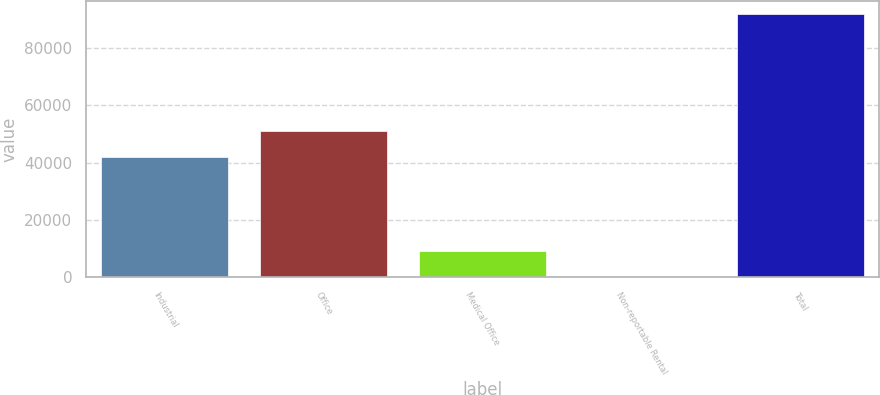Convert chart. <chart><loc_0><loc_0><loc_500><loc_500><bar_chart><fcel>Industrial<fcel>Office<fcel>Medical Office<fcel>Non-reportable Rental<fcel>Total<nl><fcel>41971<fcel>51138.7<fcel>9288.7<fcel>121<fcel>91798<nl></chart> 